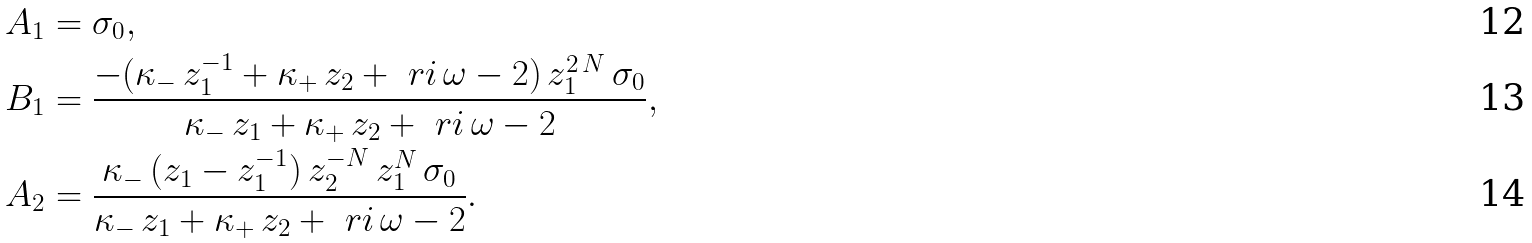<formula> <loc_0><loc_0><loc_500><loc_500>A _ { 1 } & = \sigma _ { 0 } , \\ B _ { 1 } & = \frac { - ( \kappa _ { - } \, z _ { 1 } ^ { - 1 } + \kappa _ { + } \, z _ { 2 } + \ r i \, \omega - 2 ) \, z _ { 1 } ^ { 2 \, N } \, \sigma _ { 0 } } { \kappa _ { - } \, z _ { 1 } + \kappa _ { + } \, z _ { 2 } + \ r i \, \omega - 2 } , \\ A _ { 2 } & = \frac { \kappa _ { - } \, ( z _ { 1 } - z _ { 1 } ^ { - 1 } ) \, z _ { 2 } ^ { - N } \, z _ { 1 } ^ { N } \, \sigma _ { 0 } } { \kappa _ { - } \, z _ { 1 } + \kappa _ { + } \, z _ { 2 } + \ r i \, \omega - 2 } .</formula> 